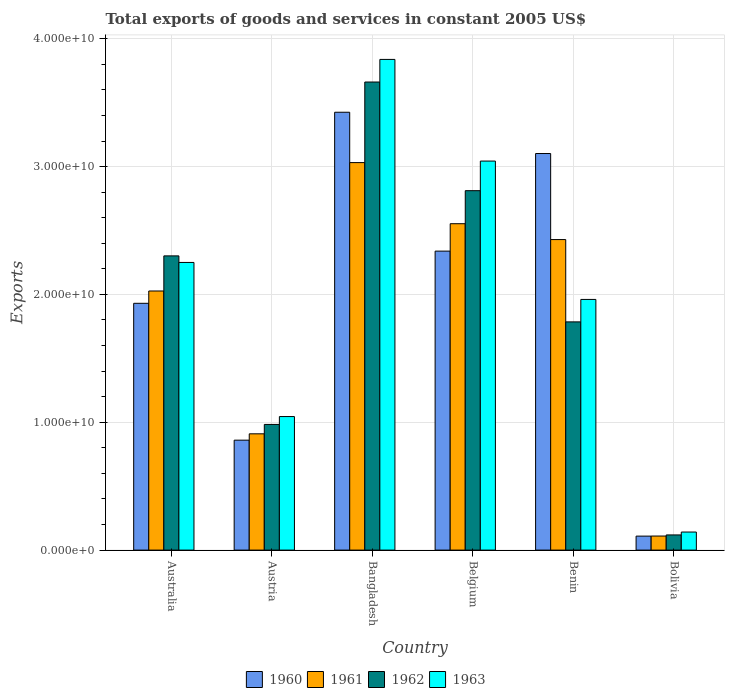How many different coloured bars are there?
Offer a very short reply. 4. How many bars are there on the 6th tick from the left?
Make the answer very short. 4. What is the label of the 5th group of bars from the left?
Ensure brevity in your answer.  Benin. What is the total exports of goods and services in 1961 in Benin?
Your response must be concise. 2.43e+1. Across all countries, what is the maximum total exports of goods and services in 1961?
Your answer should be very brief. 3.03e+1. Across all countries, what is the minimum total exports of goods and services in 1960?
Offer a terse response. 1.09e+09. In which country was the total exports of goods and services in 1961 maximum?
Provide a succinct answer. Bangladesh. What is the total total exports of goods and services in 1960 in the graph?
Offer a terse response. 1.18e+11. What is the difference between the total exports of goods and services in 1962 in Australia and that in Belgium?
Provide a succinct answer. -5.10e+09. What is the difference between the total exports of goods and services in 1963 in Australia and the total exports of goods and services in 1962 in Benin?
Provide a short and direct response. 4.65e+09. What is the average total exports of goods and services in 1961 per country?
Your answer should be very brief. 1.84e+1. What is the difference between the total exports of goods and services of/in 1960 and total exports of goods and services of/in 1962 in Bolivia?
Your response must be concise. -9.32e+07. What is the ratio of the total exports of goods and services in 1962 in Bangladesh to that in Bolivia?
Offer a terse response. 30.84. Is the total exports of goods and services in 1961 in Bangladesh less than that in Benin?
Your response must be concise. No. Is the difference between the total exports of goods and services in 1960 in Bangladesh and Benin greater than the difference between the total exports of goods and services in 1962 in Bangladesh and Benin?
Give a very brief answer. No. What is the difference between the highest and the second highest total exports of goods and services in 1961?
Your answer should be very brief. -4.78e+09. What is the difference between the highest and the lowest total exports of goods and services in 1960?
Make the answer very short. 3.32e+1. In how many countries, is the total exports of goods and services in 1960 greater than the average total exports of goods and services in 1960 taken over all countries?
Your response must be concise. 3. Is it the case that in every country, the sum of the total exports of goods and services in 1962 and total exports of goods and services in 1961 is greater than the sum of total exports of goods and services in 1960 and total exports of goods and services in 1963?
Keep it short and to the point. No. How many countries are there in the graph?
Your answer should be very brief. 6. Are the values on the major ticks of Y-axis written in scientific E-notation?
Ensure brevity in your answer.  Yes. Does the graph contain any zero values?
Keep it short and to the point. No. Does the graph contain grids?
Give a very brief answer. Yes. How many legend labels are there?
Your answer should be compact. 4. How are the legend labels stacked?
Your answer should be compact. Horizontal. What is the title of the graph?
Your answer should be very brief. Total exports of goods and services in constant 2005 US$. Does "1998" appear as one of the legend labels in the graph?
Your response must be concise. No. What is the label or title of the Y-axis?
Your response must be concise. Exports. What is the Exports of 1960 in Australia?
Your response must be concise. 1.93e+1. What is the Exports in 1961 in Australia?
Offer a very short reply. 2.03e+1. What is the Exports in 1962 in Australia?
Your answer should be compact. 2.30e+1. What is the Exports in 1963 in Australia?
Provide a succinct answer. 2.25e+1. What is the Exports of 1960 in Austria?
Your answer should be very brief. 8.60e+09. What is the Exports of 1961 in Austria?
Make the answer very short. 9.10e+09. What is the Exports of 1962 in Austria?
Your answer should be very brief. 9.83e+09. What is the Exports of 1963 in Austria?
Offer a terse response. 1.04e+1. What is the Exports of 1960 in Bangladesh?
Offer a terse response. 3.42e+1. What is the Exports in 1961 in Bangladesh?
Provide a short and direct response. 3.03e+1. What is the Exports in 1962 in Bangladesh?
Your response must be concise. 3.66e+1. What is the Exports of 1963 in Bangladesh?
Provide a succinct answer. 3.84e+1. What is the Exports of 1960 in Belgium?
Your answer should be very brief. 2.34e+1. What is the Exports of 1961 in Belgium?
Provide a succinct answer. 2.55e+1. What is the Exports in 1962 in Belgium?
Ensure brevity in your answer.  2.81e+1. What is the Exports of 1963 in Belgium?
Your answer should be very brief. 3.04e+1. What is the Exports of 1960 in Benin?
Your answer should be very brief. 3.10e+1. What is the Exports of 1961 in Benin?
Make the answer very short. 2.43e+1. What is the Exports of 1962 in Benin?
Your answer should be compact. 1.79e+1. What is the Exports in 1963 in Benin?
Keep it short and to the point. 1.96e+1. What is the Exports in 1960 in Bolivia?
Your answer should be very brief. 1.09e+09. What is the Exports of 1961 in Bolivia?
Keep it short and to the point. 1.10e+09. What is the Exports in 1962 in Bolivia?
Your answer should be compact. 1.19e+09. What is the Exports in 1963 in Bolivia?
Offer a very short reply. 1.41e+09. Across all countries, what is the maximum Exports in 1960?
Ensure brevity in your answer.  3.42e+1. Across all countries, what is the maximum Exports in 1961?
Provide a short and direct response. 3.03e+1. Across all countries, what is the maximum Exports in 1962?
Provide a succinct answer. 3.66e+1. Across all countries, what is the maximum Exports in 1963?
Offer a very short reply. 3.84e+1. Across all countries, what is the minimum Exports of 1960?
Ensure brevity in your answer.  1.09e+09. Across all countries, what is the minimum Exports in 1961?
Offer a very short reply. 1.10e+09. Across all countries, what is the minimum Exports in 1962?
Offer a terse response. 1.19e+09. Across all countries, what is the minimum Exports in 1963?
Offer a terse response. 1.41e+09. What is the total Exports of 1960 in the graph?
Provide a succinct answer. 1.18e+11. What is the total Exports in 1961 in the graph?
Your answer should be compact. 1.11e+11. What is the total Exports in 1962 in the graph?
Your response must be concise. 1.17e+11. What is the total Exports of 1963 in the graph?
Offer a terse response. 1.23e+11. What is the difference between the Exports of 1960 in Australia and that in Austria?
Your answer should be very brief. 1.07e+1. What is the difference between the Exports of 1961 in Australia and that in Austria?
Provide a short and direct response. 1.12e+1. What is the difference between the Exports of 1962 in Australia and that in Austria?
Make the answer very short. 1.32e+1. What is the difference between the Exports of 1963 in Australia and that in Austria?
Give a very brief answer. 1.21e+1. What is the difference between the Exports in 1960 in Australia and that in Bangladesh?
Keep it short and to the point. -1.49e+1. What is the difference between the Exports in 1961 in Australia and that in Bangladesh?
Your response must be concise. -1.00e+1. What is the difference between the Exports in 1962 in Australia and that in Bangladesh?
Your answer should be compact. -1.36e+1. What is the difference between the Exports of 1963 in Australia and that in Bangladesh?
Your answer should be compact. -1.59e+1. What is the difference between the Exports in 1960 in Australia and that in Belgium?
Provide a short and direct response. -4.08e+09. What is the difference between the Exports of 1961 in Australia and that in Belgium?
Your response must be concise. -5.26e+09. What is the difference between the Exports of 1962 in Australia and that in Belgium?
Make the answer very short. -5.10e+09. What is the difference between the Exports in 1963 in Australia and that in Belgium?
Your answer should be very brief. -7.93e+09. What is the difference between the Exports in 1960 in Australia and that in Benin?
Offer a terse response. -1.17e+1. What is the difference between the Exports in 1961 in Australia and that in Benin?
Give a very brief answer. -4.02e+09. What is the difference between the Exports of 1962 in Australia and that in Benin?
Give a very brief answer. 5.16e+09. What is the difference between the Exports in 1963 in Australia and that in Benin?
Your answer should be very brief. 2.89e+09. What is the difference between the Exports of 1960 in Australia and that in Bolivia?
Your response must be concise. 1.82e+1. What is the difference between the Exports of 1961 in Australia and that in Bolivia?
Your answer should be very brief. 1.92e+1. What is the difference between the Exports of 1962 in Australia and that in Bolivia?
Give a very brief answer. 2.18e+1. What is the difference between the Exports in 1963 in Australia and that in Bolivia?
Your response must be concise. 2.11e+1. What is the difference between the Exports in 1960 in Austria and that in Bangladesh?
Keep it short and to the point. -2.57e+1. What is the difference between the Exports in 1961 in Austria and that in Bangladesh?
Keep it short and to the point. -2.12e+1. What is the difference between the Exports in 1962 in Austria and that in Bangladesh?
Ensure brevity in your answer.  -2.68e+1. What is the difference between the Exports of 1963 in Austria and that in Bangladesh?
Offer a terse response. -2.79e+1. What is the difference between the Exports in 1960 in Austria and that in Belgium?
Offer a very short reply. -1.48e+1. What is the difference between the Exports in 1961 in Austria and that in Belgium?
Keep it short and to the point. -1.64e+1. What is the difference between the Exports in 1962 in Austria and that in Belgium?
Make the answer very short. -1.83e+1. What is the difference between the Exports of 1963 in Austria and that in Belgium?
Provide a short and direct response. -2.00e+1. What is the difference between the Exports of 1960 in Austria and that in Benin?
Keep it short and to the point. -2.24e+1. What is the difference between the Exports of 1961 in Austria and that in Benin?
Make the answer very short. -1.52e+1. What is the difference between the Exports of 1962 in Austria and that in Benin?
Ensure brevity in your answer.  -8.02e+09. What is the difference between the Exports in 1963 in Austria and that in Benin?
Make the answer very short. -9.16e+09. What is the difference between the Exports of 1960 in Austria and that in Bolivia?
Keep it short and to the point. 7.51e+09. What is the difference between the Exports in 1961 in Austria and that in Bolivia?
Your answer should be compact. 8.00e+09. What is the difference between the Exports of 1962 in Austria and that in Bolivia?
Offer a very short reply. 8.64e+09. What is the difference between the Exports in 1963 in Austria and that in Bolivia?
Give a very brief answer. 9.03e+09. What is the difference between the Exports in 1960 in Bangladesh and that in Belgium?
Your response must be concise. 1.09e+1. What is the difference between the Exports in 1961 in Bangladesh and that in Belgium?
Ensure brevity in your answer.  4.78e+09. What is the difference between the Exports of 1962 in Bangladesh and that in Belgium?
Make the answer very short. 8.50e+09. What is the difference between the Exports in 1963 in Bangladesh and that in Belgium?
Offer a very short reply. 7.95e+09. What is the difference between the Exports in 1960 in Bangladesh and that in Benin?
Your answer should be very brief. 3.23e+09. What is the difference between the Exports in 1961 in Bangladesh and that in Benin?
Your answer should be compact. 6.02e+09. What is the difference between the Exports of 1962 in Bangladesh and that in Benin?
Your answer should be very brief. 1.88e+1. What is the difference between the Exports in 1963 in Bangladesh and that in Benin?
Provide a succinct answer. 1.88e+1. What is the difference between the Exports of 1960 in Bangladesh and that in Bolivia?
Your response must be concise. 3.32e+1. What is the difference between the Exports in 1961 in Bangladesh and that in Bolivia?
Your response must be concise. 2.92e+1. What is the difference between the Exports in 1962 in Bangladesh and that in Bolivia?
Offer a very short reply. 3.54e+1. What is the difference between the Exports in 1963 in Bangladesh and that in Bolivia?
Provide a succinct answer. 3.70e+1. What is the difference between the Exports of 1960 in Belgium and that in Benin?
Your response must be concise. -7.63e+09. What is the difference between the Exports of 1961 in Belgium and that in Benin?
Provide a short and direct response. 1.24e+09. What is the difference between the Exports in 1962 in Belgium and that in Benin?
Offer a terse response. 1.03e+1. What is the difference between the Exports in 1963 in Belgium and that in Benin?
Your answer should be compact. 1.08e+1. What is the difference between the Exports of 1960 in Belgium and that in Bolivia?
Your answer should be very brief. 2.23e+1. What is the difference between the Exports in 1961 in Belgium and that in Bolivia?
Ensure brevity in your answer.  2.44e+1. What is the difference between the Exports of 1962 in Belgium and that in Bolivia?
Give a very brief answer. 2.69e+1. What is the difference between the Exports in 1963 in Belgium and that in Bolivia?
Give a very brief answer. 2.90e+1. What is the difference between the Exports in 1960 in Benin and that in Bolivia?
Your response must be concise. 2.99e+1. What is the difference between the Exports of 1961 in Benin and that in Bolivia?
Give a very brief answer. 2.32e+1. What is the difference between the Exports in 1962 in Benin and that in Bolivia?
Offer a very short reply. 1.67e+1. What is the difference between the Exports in 1963 in Benin and that in Bolivia?
Make the answer very short. 1.82e+1. What is the difference between the Exports in 1960 in Australia and the Exports in 1961 in Austria?
Offer a very short reply. 1.02e+1. What is the difference between the Exports in 1960 in Australia and the Exports in 1962 in Austria?
Your answer should be very brief. 9.47e+09. What is the difference between the Exports of 1960 in Australia and the Exports of 1963 in Austria?
Keep it short and to the point. 8.86e+09. What is the difference between the Exports of 1961 in Australia and the Exports of 1962 in Austria?
Provide a succinct answer. 1.04e+1. What is the difference between the Exports in 1961 in Australia and the Exports in 1963 in Austria?
Provide a succinct answer. 9.82e+09. What is the difference between the Exports in 1962 in Australia and the Exports in 1963 in Austria?
Offer a very short reply. 1.26e+1. What is the difference between the Exports in 1960 in Australia and the Exports in 1961 in Bangladesh?
Give a very brief answer. -1.10e+1. What is the difference between the Exports of 1960 in Australia and the Exports of 1962 in Bangladesh?
Your answer should be compact. -1.73e+1. What is the difference between the Exports of 1960 in Australia and the Exports of 1963 in Bangladesh?
Offer a very short reply. -1.91e+1. What is the difference between the Exports in 1961 in Australia and the Exports in 1962 in Bangladesh?
Keep it short and to the point. -1.63e+1. What is the difference between the Exports in 1961 in Australia and the Exports in 1963 in Bangladesh?
Your answer should be compact. -1.81e+1. What is the difference between the Exports in 1962 in Australia and the Exports in 1963 in Bangladesh?
Give a very brief answer. -1.54e+1. What is the difference between the Exports in 1960 in Australia and the Exports in 1961 in Belgium?
Your response must be concise. -6.23e+09. What is the difference between the Exports of 1960 in Australia and the Exports of 1962 in Belgium?
Your answer should be compact. -8.81e+09. What is the difference between the Exports in 1960 in Australia and the Exports in 1963 in Belgium?
Provide a short and direct response. -1.11e+1. What is the difference between the Exports of 1961 in Australia and the Exports of 1962 in Belgium?
Give a very brief answer. -7.85e+09. What is the difference between the Exports in 1961 in Australia and the Exports in 1963 in Belgium?
Offer a very short reply. -1.02e+1. What is the difference between the Exports of 1962 in Australia and the Exports of 1963 in Belgium?
Your answer should be very brief. -7.42e+09. What is the difference between the Exports in 1960 in Australia and the Exports in 1961 in Benin?
Give a very brief answer. -4.99e+09. What is the difference between the Exports of 1960 in Australia and the Exports of 1962 in Benin?
Give a very brief answer. 1.45e+09. What is the difference between the Exports of 1960 in Australia and the Exports of 1963 in Benin?
Provide a succinct answer. -3.03e+08. What is the difference between the Exports of 1961 in Australia and the Exports of 1962 in Benin?
Offer a terse response. 2.42e+09. What is the difference between the Exports in 1961 in Australia and the Exports in 1963 in Benin?
Your answer should be very brief. 6.60e+08. What is the difference between the Exports of 1962 in Australia and the Exports of 1963 in Benin?
Your answer should be very brief. 3.41e+09. What is the difference between the Exports in 1960 in Australia and the Exports in 1961 in Bolivia?
Offer a terse response. 1.82e+1. What is the difference between the Exports of 1960 in Australia and the Exports of 1962 in Bolivia?
Your answer should be very brief. 1.81e+1. What is the difference between the Exports in 1960 in Australia and the Exports in 1963 in Bolivia?
Offer a very short reply. 1.79e+1. What is the difference between the Exports in 1961 in Australia and the Exports in 1962 in Bolivia?
Your answer should be compact. 1.91e+1. What is the difference between the Exports of 1961 in Australia and the Exports of 1963 in Bolivia?
Provide a short and direct response. 1.89e+1. What is the difference between the Exports in 1962 in Australia and the Exports in 1963 in Bolivia?
Your answer should be compact. 2.16e+1. What is the difference between the Exports of 1960 in Austria and the Exports of 1961 in Bangladesh?
Ensure brevity in your answer.  -2.17e+1. What is the difference between the Exports in 1960 in Austria and the Exports in 1962 in Bangladesh?
Offer a terse response. -2.80e+1. What is the difference between the Exports of 1960 in Austria and the Exports of 1963 in Bangladesh?
Provide a succinct answer. -2.98e+1. What is the difference between the Exports of 1961 in Austria and the Exports of 1962 in Bangladesh?
Give a very brief answer. -2.75e+1. What is the difference between the Exports in 1961 in Austria and the Exports in 1963 in Bangladesh?
Your answer should be very brief. -2.93e+1. What is the difference between the Exports in 1962 in Austria and the Exports in 1963 in Bangladesh?
Keep it short and to the point. -2.86e+1. What is the difference between the Exports in 1960 in Austria and the Exports in 1961 in Belgium?
Keep it short and to the point. -1.69e+1. What is the difference between the Exports of 1960 in Austria and the Exports of 1962 in Belgium?
Make the answer very short. -1.95e+1. What is the difference between the Exports in 1960 in Austria and the Exports in 1963 in Belgium?
Offer a terse response. -2.18e+1. What is the difference between the Exports in 1961 in Austria and the Exports in 1962 in Belgium?
Make the answer very short. -1.90e+1. What is the difference between the Exports in 1961 in Austria and the Exports in 1963 in Belgium?
Ensure brevity in your answer.  -2.13e+1. What is the difference between the Exports in 1962 in Austria and the Exports in 1963 in Belgium?
Make the answer very short. -2.06e+1. What is the difference between the Exports in 1960 in Austria and the Exports in 1961 in Benin?
Make the answer very short. -1.57e+1. What is the difference between the Exports in 1960 in Austria and the Exports in 1962 in Benin?
Provide a succinct answer. -9.25e+09. What is the difference between the Exports in 1960 in Austria and the Exports in 1963 in Benin?
Offer a terse response. -1.10e+1. What is the difference between the Exports in 1961 in Austria and the Exports in 1962 in Benin?
Make the answer very short. -8.76e+09. What is the difference between the Exports of 1961 in Austria and the Exports of 1963 in Benin?
Your response must be concise. -1.05e+1. What is the difference between the Exports of 1962 in Austria and the Exports of 1963 in Benin?
Your response must be concise. -9.78e+09. What is the difference between the Exports in 1960 in Austria and the Exports in 1961 in Bolivia?
Keep it short and to the point. 7.50e+09. What is the difference between the Exports of 1960 in Austria and the Exports of 1962 in Bolivia?
Ensure brevity in your answer.  7.41e+09. What is the difference between the Exports of 1960 in Austria and the Exports of 1963 in Bolivia?
Keep it short and to the point. 7.19e+09. What is the difference between the Exports in 1961 in Austria and the Exports in 1962 in Bolivia?
Give a very brief answer. 7.91e+09. What is the difference between the Exports in 1961 in Austria and the Exports in 1963 in Bolivia?
Ensure brevity in your answer.  7.68e+09. What is the difference between the Exports of 1962 in Austria and the Exports of 1963 in Bolivia?
Your response must be concise. 8.42e+09. What is the difference between the Exports in 1960 in Bangladesh and the Exports in 1961 in Belgium?
Provide a short and direct response. 8.72e+09. What is the difference between the Exports of 1960 in Bangladesh and the Exports of 1962 in Belgium?
Offer a terse response. 6.14e+09. What is the difference between the Exports in 1960 in Bangladesh and the Exports in 1963 in Belgium?
Your answer should be compact. 3.82e+09. What is the difference between the Exports in 1961 in Bangladesh and the Exports in 1962 in Belgium?
Your answer should be very brief. 2.20e+09. What is the difference between the Exports in 1961 in Bangladesh and the Exports in 1963 in Belgium?
Provide a succinct answer. -1.20e+08. What is the difference between the Exports in 1962 in Bangladesh and the Exports in 1963 in Belgium?
Offer a terse response. 6.18e+09. What is the difference between the Exports of 1960 in Bangladesh and the Exports of 1961 in Benin?
Provide a succinct answer. 9.96e+09. What is the difference between the Exports in 1960 in Bangladesh and the Exports in 1962 in Benin?
Offer a very short reply. 1.64e+1. What is the difference between the Exports of 1960 in Bangladesh and the Exports of 1963 in Benin?
Give a very brief answer. 1.46e+1. What is the difference between the Exports in 1961 in Bangladesh and the Exports in 1962 in Benin?
Your answer should be very brief. 1.25e+1. What is the difference between the Exports in 1961 in Bangladesh and the Exports in 1963 in Benin?
Your answer should be very brief. 1.07e+1. What is the difference between the Exports in 1962 in Bangladesh and the Exports in 1963 in Benin?
Ensure brevity in your answer.  1.70e+1. What is the difference between the Exports of 1960 in Bangladesh and the Exports of 1961 in Bolivia?
Offer a terse response. 3.31e+1. What is the difference between the Exports of 1960 in Bangladesh and the Exports of 1962 in Bolivia?
Keep it short and to the point. 3.31e+1. What is the difference between the Exports in 1960 in Bangladesh and the Exports in 1963 in Bolivia?
Provide a succinct answer. 3.28e+1. What is the difference between the Exports of 1961 in Bangladesh and the Exports of 1962 in Bolivia?
Your response must be concise. 2.91e+1. What is the difference between the Exports of 1961 in Bangladesh and the Exports of 1963 in Bolivia?
Keep it short and to the point. 2.89e+1. What is the difference between the Exports of 1962 in Bangladesh and the Exports of 1963 in Bolivia?
Give a very brief answer. 3.52e+1. What is the difference between the Exports of 1960 in Belgium and the Exports of 1961 in Benin?
Your answer should be very brief. -9.03e+08. What is the difference between the Exports in 1960 in Belgium and the Exports in 1962 in Benin?
Provide a short and direct response. 5.54e+09. What is the difference between the Exports of 1960 in Belgium and the Exports of 1963 in Benin?
Provide a succinct answer. 3.78e+09. What is the difference between the Exports in 1961 in Belgium and the Exports in 1962 in Benin?
Make the answer very short. 7.68e+09. What is the difference between the Exports in 1961 in Belgium and the Exports in 1963 in Benin?
Provide a succinct answer. 5.92e+09. What is the difference between the Exports of 1962 in Belgium and the Exports of 1963 in Benin?
Offer a very short reply. 8.51e+09. What is the difference between the Exports in 1960 in Belgium and the Exports in 1961 in Bolivia?
Provide a short and direct response. 2.23e+1. What is the difference between the Exports of 1960 in Belgium and the Exports of 1962 in Bolivia?
Provide a short and direct response. 2.22e+1. What is the difference between the Exports in 1960 in Belgium and the Exports in 1963 in Bolivia?
Ensure brevity in your answer.  2.20e+1. What is the difference between the Exports in 1961 in Belgium and the Exports in 1962 in Bolivia?
Keep it short and to the point. 2.43e+1. What is the difference between the Exports of 1961 in Belgium and the Exports of 1963 in Bolivia?
Offer a terse response. 2.41e+1. What is the difference between the Exports of 1962 in Belgium and the Exports of 1963 in Bolivia?
Ensure brevity in your answer.  2.67e+1. What is the difference between the Exports of 1960 in Benin and the Exports of 1961 in Bolivia?
Give a very brief answer. 2.99e+1. What is the difference between the Exports of 1960 in Benin and the Exports of 1962 in Bolivia?
Your answer should be very brief. 2.98e+1. What is the difference between the Exports of 1960 in Benin and the Exports of 1963 in Bolivia?
Your response must be concise. 2.96e+1. What is the difference between the Exports of 1961 in Benin and the Exports of 1962 in Bolivia?
Offer a terse response. 2.31e+1. What is the difference between the Exports of 1961 in Benin and the Exports of 1963 in Bolivia?
Give a very brief answer. 2.29e+1. What is the difference between the Exports in 1962 in Benin and the Exports in 1963 in Bolivia?
Your response must be concise. 1.64e+1. What is the average Exports in 1960 per country?
Ensure brevity in your answer.  1.96e+1. What is the average Exports of 1961 per country?
Your answer should be very brief. 1.84e+1. What is the average Exports of 1962 per country?
Keep it short and to the point. 1.94e+1. What is the average Exports of 1963 per country?
Make the answer very short. 2.05e+1. What is the difference between the Exports in 1960 and Exports in 1961 in Australia?
Provide a short and direct response. -9.63e+08. What is the difference between the Exports in 1960 and Exports in 1962 in Australia?
Ensure brevity in your answer.  -3.71e+09. What is the difference between the Exports of 1960 and Exports of 1963 in Australia?
Provide a short and direct response. -3.20e+09. What is the difference between the Exports of 1961 and Exports of 1962 in Australia?
Keep it short and to the point. -2.75e+09. What is the difference between the Exports of 1961 and Exports of 1963 in Australia?
Provide a succinct answer. -2.23e+09. What is the difference between the Exports in 1962 and Exports in 1963 in Australia?
Your answer should be very brief. 5.13e+08. What is the difference between the Exports in 1960 and Exports in 1961 in Austria?
Provide a succinct answer. -4.96e+08. What is the difference between the Exports of 1960 and Exports of 1962 in Austria?
Provide a succinct answer. -1.23e+09. What is the difference between the Exports of 1960 and Exports of 1963 in Austria?
Give a very brief answer. -1.85e+09. What is the difference between the Exports of 1961 and Exports of 1962 in Austria?
Your answer should be very brief. -7.35e+08. What is the difference between the Exports of 1961 and Exports of 1963 in Austria?
Give a very brief answer. -1.35e+09. What is the difference between the Exports of 1962 and Exports of 1963 in Austria?
Give a very brief answer. -6.16e+08. What is the difference between the Exports in 1960 and Exports in 1961 in Bangladesh?
Your answer should be very brief. 3.94e+09. What is the difference between the Exports of 1960 and Exports of 1962 in Bangladesh?
Ensure brevity in your answer.  -2.36e+09. What is the difference between the Exports in 1960 and Exports in 1963 in Bangladesh?
Make the answer very short. -4.13e+09. What is the difference between the Exports of 1961 and Exports of 1962 in Bangladesh?
Your answer should be compact. -6.30e+09. What is the difference between the Exports in 1961 and Exports in 1963 in Bangladesh?
Your response must be concise. -8.07e+09. What is the difference between the Exports of 1962 and Exports of 1963 in Bangladesh?
Make the answer very short. -1.77e+09. What is the difference between the Exports of 1960 and Exports of 1961 in Belgium?
Provide a succinct answer. -2.14e+09. What is the difference between the Exports of 1960 and Exports of 1962 in Belgium?
Your response must be concise. -4.73e+09. What is the difference between the Exports in 1960 and Exports in 1963 in Belgium?
Give a very brief answer. -7.04e+09. What is the difference between the Exports of 1961 and Exports of 1962 in Belgium?
Offer a terse response. -2.58e+09. What is the difference between the Exports in 1961 and Exports in 1963 in Belgium?
Keep it short and to the point. -4.90e+09. What is the difference between the Exports of 1962 and Exports of 1963 in Belgium?
Keep it short and to the point. -2.32e+09. What is the difference between the Exports in 1960 and Exports in 1961 in Benin?
Your answer should be compact. 6.73e+09. What is the difference between the Exports of 1960 and Exports of 1962 in Benin?
Provide a succinct answer. 1.32e+1. What is the difference between the Exports in 1960 and Exports in 1963 in Benin?
Offer a very short reply. 1.14e+1. What is the difference between the Exports in 1961 and Exports in 1962 in Benin?
Your answer should be very brief. 6.44e+09. What is the difference between the Exports of 1961 and Exports of 1963 in Benin?
Offer a very short reply. 4.68e+09. What is the difference between the Exports in 1962 and Exports in 1963 in Benin?
Give a very brief answer. -1.76e+09. What is the difference between the Exports in 1960 and Exports in 1961 in Bolivia?
Provide a short and direct response. -6.43e+06. What is the difference between the Exports of 1960 and Exports of 1962 in Bolivia?
Your response must be concise. -9.32e+07. What is the difference between the Exports in 1960 and Exports in 1963 in Bolivia?
Make the answer very short. -3.18e+08. What is the difference between the Exports of 1961 and Exports of 1962 in Bolivia?
Provide a succinct answer. -8.67e+07. What is the difference between the Exports in 1961 and Exports in 1963 in Bolivia?
Offer a very short reply. -3.12e+08. What is the difference between the Exports of 1962 and Exports of 1963 in Bolivia?
Provide a succinct answer. -2.25e+08. What is the ratio of the Exports in 1960 in Australia to that in Austria?
Your answer should be very brief. 2.25. What is the ratio of the Exports of 1961 in Australia to that in Austria?
Keep it short and to the point. 2.23. What is the ratio of the Exports of 1962 in Australia to that in Austria?
Your answer should be compact. 2.34. What is the ratio of the Exports of 1963 in Australia to that in Austria?
Provide a short and direct response. 2.15. What is the ratio of the Exports of 1960 in Australia to that in Bangladesh?
Keep it short and to the point. 0.56. What is the ratio of the Exports of 1961 in Australia to that in Bangladesh?
Your response must be concise. 0.67. What is the ratio of the Exports in 1962 in Australia to that in Bangladesh?
Ensure brevity in your answer.  0.63. What is the ratio of the Exports of 1963 in Australia to that in Bangladesh?
Keep it short and to the point. 0.59. What is the ratio of the Exports of 1960 in Australia to that in Belgium?
Offer a very short reply. 0.83. What is the ratio of the Exports of 1961 in Australia to that in Belgium?
Give a very brief answer. 0.79. What is the ratio of the Exports of 1962 in Australia to that in Belgium?
Make the answer very short. 0.82. What is the ratio of the Exports of 1963 in Australia to that in Belgium?
Your answer should be very brief. 0.74. What is the ratio of the Exports of 1960 in Australia to that in Benin?
Provide a short and direct response. 0.62. What is the ratio of the Exports in 1961 in Australia to that in Benin?
Provide a succinct answer. 0.83. What is the ratio of the Exports in 1962 in Australia to that in Benin?
Give a very brief answer. 1.29. What is the ratio of the Exports of 1963 in Australia to that in Benin?
Offer a very short reply. 1.15. What is the ratio of the Exports in 1960 in Australia to that in Bolivia?
Offer a very short reply. 17.65. What is the ratio of the Exports in 1961 in Australia to that in Bolivia?
Your answer should be very brief. 18.42. What is the ratio of the Exports in 1962 in Australia to that in Bolivia?
Provide a succinct answer. 19.39. What is the ratio of the Exports of 1963 in Australia to that in Bolivia?
Ensure brevity in your answer.  15.93. What is the ratio of the Exports of 1960 in Austria to that in Bangladesh?
Your answer should be very brief. 0.25. What is the ratio of the Exports of 1961 in Austria to that in Bangladesh?
Your answer should be very brief. 0.3. What is the ratio of the Exports in 1962 in Austria to that in Bangladesh?
Your response must be concise. 0.27. What is the ratio of the Exports in 1963 in Austria to that in Bangladesh?
Give a very brief answer. 0.27. What is the ratio of the Exports of 1960 in Austria to that in Belgium?
Keep it short and to the point. 0.37. What is the ratio of the Exports in 1961 in Austria to that in Belgium?
Ensure brevity in your answer.  0.36. What is the ratio of the Exports in 1962 in Austria to that in Belgium?
Ensure brevity in your answer.  0.35. What is the ratio of the Exports of 1963 in Austria to that in Belgium?
Your answer should be very brief. 0.34. What is the ratio of the Exports of 1960 in Austria to that in Benin?
Offer a terse response. 0.28. What is the ratio of the Exports in 1961 in Austria to that in Benin?
Offer a very short reply. 0.37. What is the ratio of the Exports of 1962 in Austria to that in Benin?
Your response must be concise. 0.55. What is the ratio of the Exports of 1963 in Austria to that in Benin?
Provide a short and direct response. 0.53. What is the ratio of the Exports in 1960 in Austria to that in Bolivia?
Make the answer very short. 7.86. What is the ratio of the Exports in 1961 in Austria to that in Bolivia?
Keep it short and to the point. 8.27. What is the ratio of the Exports of 1962 in Austria to that in Bolivia?
Provide a short and direct response. 8.28. What is the ratio of the Exports in 1963 in Austria to that in Bolivia?
Provide a short and direct response. 7.4. What is the ratio of the Exports of 1960 in Bangladesh to that in Belgium?
Offer a terse response. 1.46. What is the ratio of the Exports of 1961 in Bangladesh to that in Belgium?
Offer a very short reply. 1.19. What is the ratio of the Exports of 1962 in Bangladesh to that in Belgium?
Make the answer very short. 1.3. What is the ratio of the Exports in 1963 in Bangladesh to that in Belgium?
Provide a short and direct response. 1.26. What is the ratio of the Exports in 1960 in Bangladesh to that in Benin?
Your answer should be compact. 1.1. What is the ratio of the Exports in 1961 in Bangladesh to that in Benin?
Ensure brevity in your answer.  1.25. What is the ratio of the Exports in 1962 in Bangladesh to that in Benin?
Your answer should be very brief. 2.05. What is the ratio of the Exports of 1963 in Bangladesh to that in Benin?
Offer a very short reply. 1.96. What is the ratio of the Exports in 1960 in Bangladesh to that in Bolivia?
Ensure brevity in your answer.  31.31. What is the ratio of the Exports of 1961 in Bangladesh to that in Bolivia?
Your response must be concise. 27.54. What is the ratio of the Exports in 1962 in Bangladesh to that in Bolivia?
Your answer should be very brief. 30.84. What is the ratio of the Exports of 1963 in Bangladesh to that in Bolivia?
Provide a succinct answer. 27.18. What is the ratio of the Exports in 1960 in Belgium to that in Benin?
Provide a short and direct response. 0.75. What is the ratio of the Exports of 1961 in Belgium to that in Benin?
Offer a terse response. 1.05. What is the ratio of the Exports of 1962 in Belgium to that in Benin?
Keep it short and to the point. 1.57. What is the ratio of the Exports in 1963 in Belgium to that in Benin?
Keep it short and to the point. 1.55. What is the ratio of the Exports of 1960 in Belgium to that in Bolivia?
Offer a terse response. 21.38. What is the ratio of the Exports of 1961 in Belgium to that in Bolivia?
Offer a very short reply. 23.2. What is the ratio of the Exports of 1962 in Belgium to that in Bolivia?
Keep it short and to the point. 23.68. What is the ratio of the Exports of 1963 in Belgium to that in Bolivia?
Provide a short and direct response. 21.55. What is the ratio of the Exports of 1960 in Benin to that in Bolivia?
Your response must be concise. 28.36. What is the ratio of the Exports in 1961 in Benin to that in Bolivia?
Your answer should be compact. 22.07. What is the ratio of the Exports of 1962 in Benin to that in Bolivia?
Provide a succinct answer. 15.04. What is the ratio of the Exports of 1963 in Benin to that in Bolivia?
Provide a short and direct response. 13.88. What is the difference between the highest and the second highest Exports in 1960?
Keep it short and to the point. 3.23e+09. What is the difference between the highest and the second highest Exports of 1961?
Ensure brevity in your answer.  4.78e+09. What is the difference between the highest and the second highest Exports of 1962?
Offer a very short reply. 8.50e+09. What is the difference between the highest and the second highest Exports of 1963?
Offer a terse response. 7.95e+09. What is the difference between the highest and the lowest Exports in 1960?
Ensure brevity in your answer.  3.32e+1. What is the difference between the highest and the lowest Exports of 1961?
Offer a very short reply. 2.92e+1. What is the difference between the highest and the lowest Exports in 1962?
Keep it short and to the point. 3.54e+1. What is the difference between the highest and the lowest Exports of 1963?
Your answer should be very brief. 3.70e+1. 